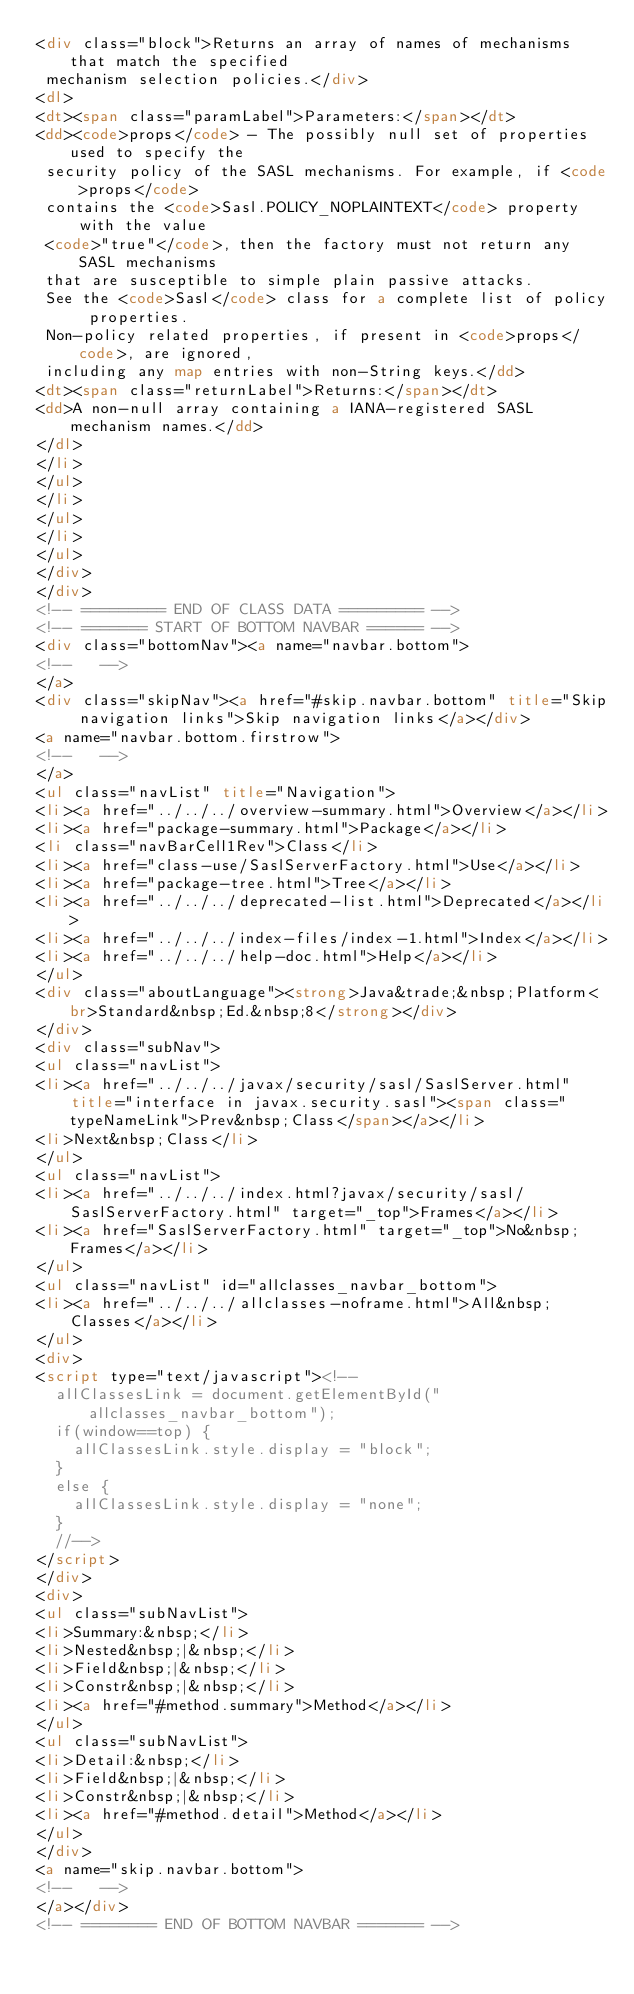Convert code to text. <code><loc_0><loc_0><loc_500><loc_500><_HTML_><div class="block">Returns an array of names of mechanisms that match the specified
 mechanism selection policies.</div>
<dl>
<dt><span class="paramLabel">Parameters:</span></dt>
<dd><code>props</code> - The possibly null set of properties used to specify the
 security policy of the SASL mechanisms. For example, if <code>props</code>
 contains the <code>Sasl.POLICY_NOPLAINTEXT</code> property with the value
 <code>"true"</code>, then the factory must not return any SASL mechanisms
 that are susceptible to simple plain passive attacks.
 See the <code>Sasl</code> class for a complete list of policy properties.
 Non-policy related properties, if present in <code>props</code>, are ignored,
 including any map entries with non-String keys.</dd>
<dt><span class="returnLabel">Returns:</span></dt>
<dd>A non-null array containing a IANA-registered SASL mechanism names.</dd>
</dl>
</li>
</ul>
</li>
</ul>
</li>
</ul>
</div>
</div>
<!-- ========= END OF CLASS DATA ========= -->
<!-- ======= START OF BOTTOM NAVBAR ====== -->
<div class="bottomNav"><a name="navbar.bottom">
<!--   -->
</a>
<div class="skipNav"><a href="#skip.navbar.bottom" title="Skip navigation links">Skip navigation links</a></div>
<a name="navbar.bottom.firstrow">
<!--   -->
</a>
<ul class="navList" title="Navigation">
<li><a href="../../../overview-summary.html">Overview</a></li>
<li><a href="package-summary.html">Package</a></li>
<li class="navBarCell1Rev">Class</li>
<li><a href="class-use/SaslServerFactory.html">Use</a></li>
<li><a href="package-tree.html">Tree</a></li>
<li><a href="../../../deprecated-list.html">Deprecated</a></li>
<li><a href="../../../index-files/index-1.html">Index</a></li>
<li><a href="../../../help-doc.html">Help</a></li>
</ul>
<div class="aboutLanguage"><strong>Java&trade;&nbsp;Platform<br>Standard&nbsp;Ed.&nbsp;8</strong></div>
</div>
<div class="subNav">
<ul class="navList">
<li><a href="../../../javax/security/sasl/SaslServer.html" title="interface in javax.security.sasl"><span class="typeNameLink">Prev&nbsp;Class</span></a></li>
<li>Next&nbsp;Class</li>
</ul>
<ul class="navList">
<li><a href="../../../index.html?javax/security/sasl/SaslServerFactory.html" target="_top">Frames</a></li>
<li><a href="SaslServerFactory.html" target="_top">No&nbsp;Frames</a></li>
</ul>
<ul class="navList" id="allclasses_navbar_bottom">
<li><a href="../../../allclasses-noframe.html">All&nbsp;Classes</a></li>
</ul>
<div>
<script type="text/javascript"><!--
  allClassesLink = document.getElementById("allclasses_navbar_bottom");
  if(window==top) {
    allClassesLink.style.display = "block";
  }
  else {
    allClassesLink.style.display = "none";
  }
  //-->
</script>
</div>
<div>
<ul class="subNavList">
<li>Summary:&nbsp;</li>
<li>Nested&nbsp;|&nbsp;</li>
<li>Field&nbsp;|&nbsp;</li>
<li>Constr&nbsp;|&nbsp;</li>
<li><a href="#method.summary">Method</a></li>
</ul>
<ul class="subNavList">
<li>Detail:&nbsp;</li>
<li>Field&nbsp;|&nbsp;</li>
<li>Constr&nbsp;|&nbsp;</li>
<li><a href="#method.detail">Method</a></li>
</ul>
</div>
<a name="skip.navbar.bottom">
<!--   -->
</a></div>
<!-- ======== END OF BOTTOM NAVBAR ======= --></code> 